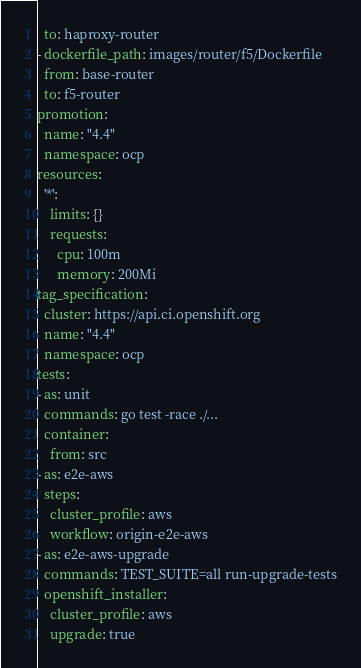Convert code to text. <code><loc_0><loc_0><loc_500><loc_500><_YAML_>  to: haproxy-router
- dockerfile_path: images/router/f5/Dockerfile
  from: base-router
  to: f5-router
promotion:
  name: "4.4"
  namespace: ocp
resources:
  '*':
    limits: {}
    requests:
      cpu: 100m
      memory: 200Mi
tag_specification:
  cluster: https://api.ci.openshift.org
  name: "4.4"
  namespace: ocp
tests:
- as: unit
  commands: go test -race ./...
  container:
    from: src
- as: e2e-aws
  steps:
    cluster_profile: aws
    workflow: origin-e2e-aws
- as: e2e-aws-upgrade
  commands: TEST_SUITE=all run-upgrade-tests
  openshift_installer:
    cluster_profile: aws
    upgrade: true
</code> 